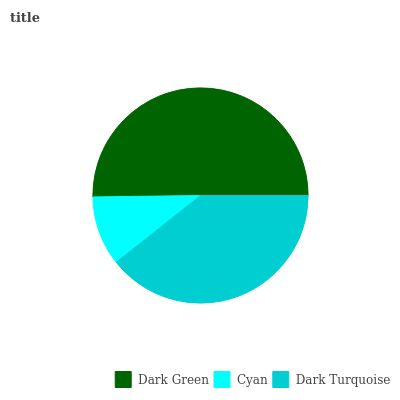Is Cyan the minimum?
Answer yes or no. Yes. Is Dark Green the maximum?
Answer yes or no. Yes. Is Dark Turquoise the minimum?
Answer yes or no. No. Is Dark Turquoise the maximum?
Answer yes or no. No. Is Dark Turquoise greater than Cyan?
Answer yes or no. Yes. Is Cyan less than Dark Turquoise?
Answer yes or no. Yes. Is Cyan greater than Dark Turquoise?
Answer yes or no. No. Is Dark Turquoise less than Cyan?
Answer yes or no. No. Is Dark Turquoise the high median?
Answer yes or no. Yes. Is Dark Turquoise the low median?
Answer yes or no. Yes. Is Dark Green the high median?
Answer yes or no. No. Is Dark Green the low median?
Answer yes or no. No. 